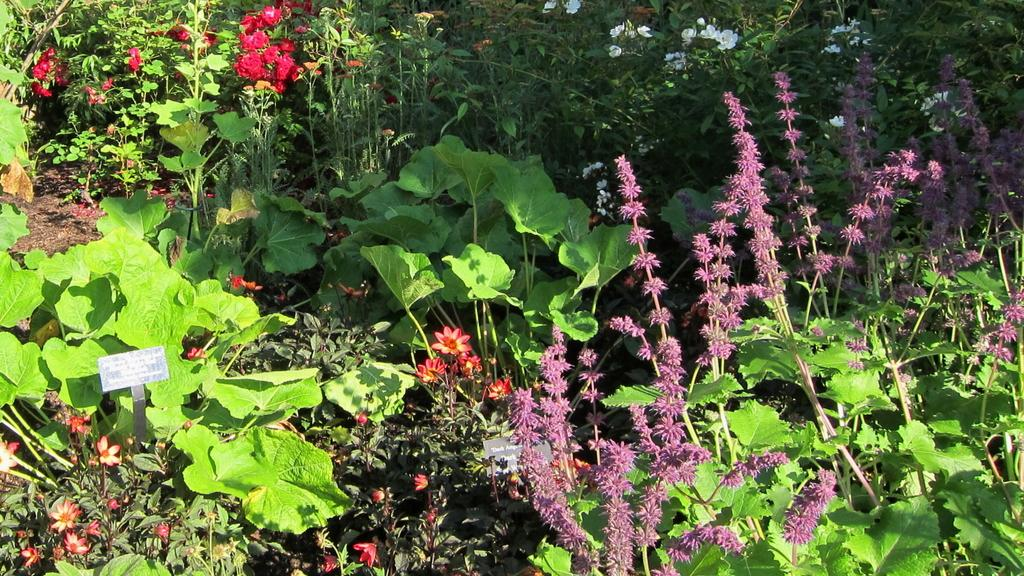What is the main subject of the image? The main subject of the image is a group of plants. What specific feature can be observed on the plants? The plants have flowers. What type of pet can be seen playing with a potato in the image? There is no pet or potato present in the image; it features a group of plants with flowers. 